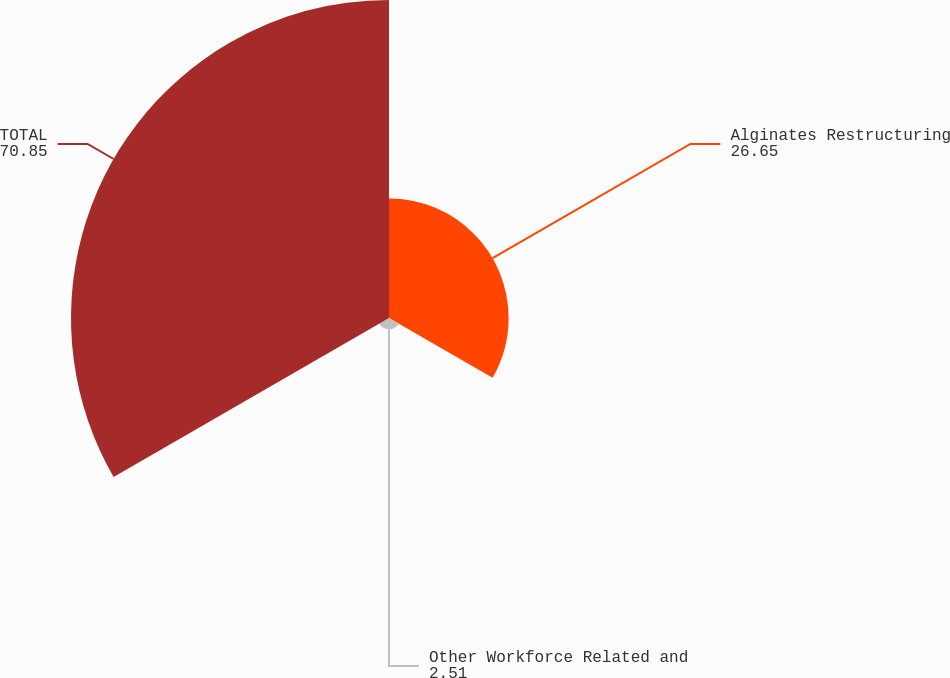Convert chart to OTSL. <chart><loc_0><loc_0><loc_500><loc_500><pie_chart><fcel>Alginates Restructuring<fcel>Other Workforce Related and<fcel>TOTAL<nl><fcel>26.65%<fcel>2.51%<fcel>70.85%<nl></chart> 